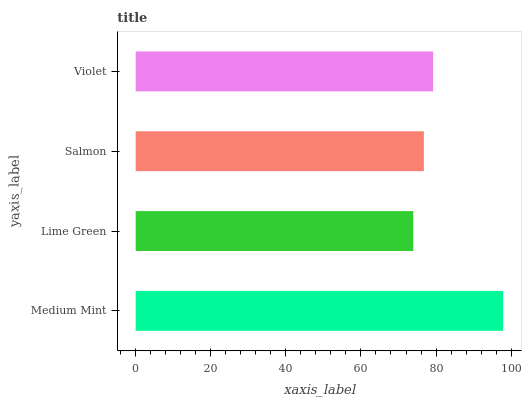Is Lime Green the minimum?
Answer yes or no. Yes. Is Medium Mint the maximum?
Answer yes or no. Yes. Is Salmon the minimum?
Answer yes or no. No. Is Salmon the maximum?
Answer yes or no. No. Is Salmon greater than Lime Green?
Answer yes or no. Yes. Is Lime Green less than Salmon?
Answer yes or no. Yes. Is Lime Green greater than Salmon?
Answer yes or no. No. Is Salmon less than Lime Green?
Answer yes or no. No. Is Violet the high median?
Answer yes or no. Yes. Is Salmon the low median?
Answer yes or no. Yes. Is Salmon the high median?
Answer yes or no. No. Is Violet the low median?
Answer yes or no. No. 